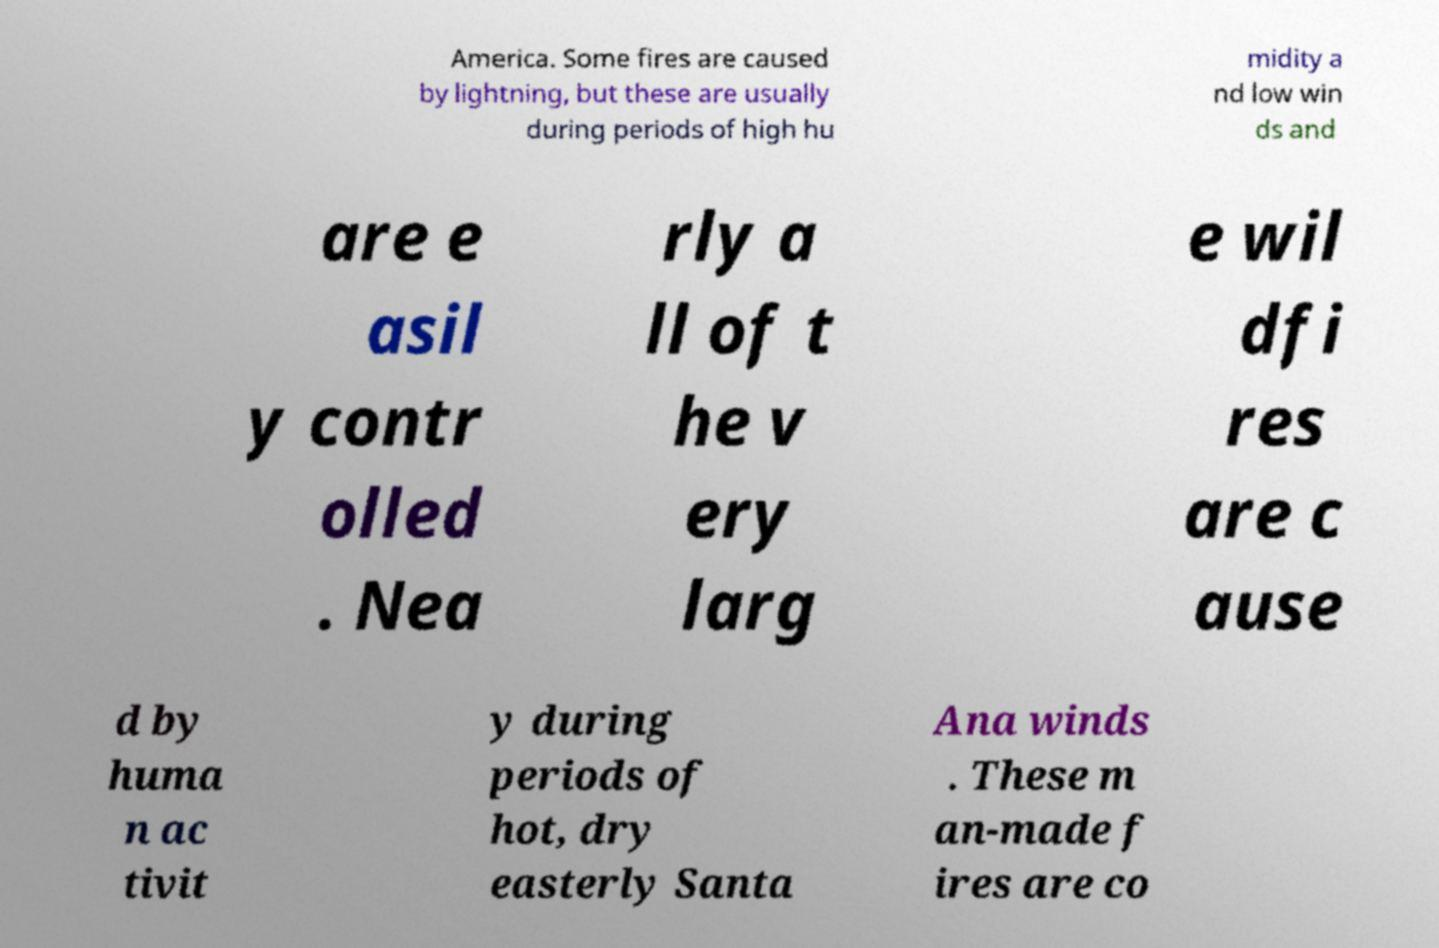Could you assist in decoding the text presented in this image and type it out clearly? America. Some fires are caused by lightning, but these are usually during periods of high hu midity a nd low win ds and are e asil y contr olled . Nea rly a ll of t he v ery larg e wil dfi res are c ause d by huma n ac tivit y during periods of hot, dry easterly Santa Ana winds . These m an-made f ires are co 